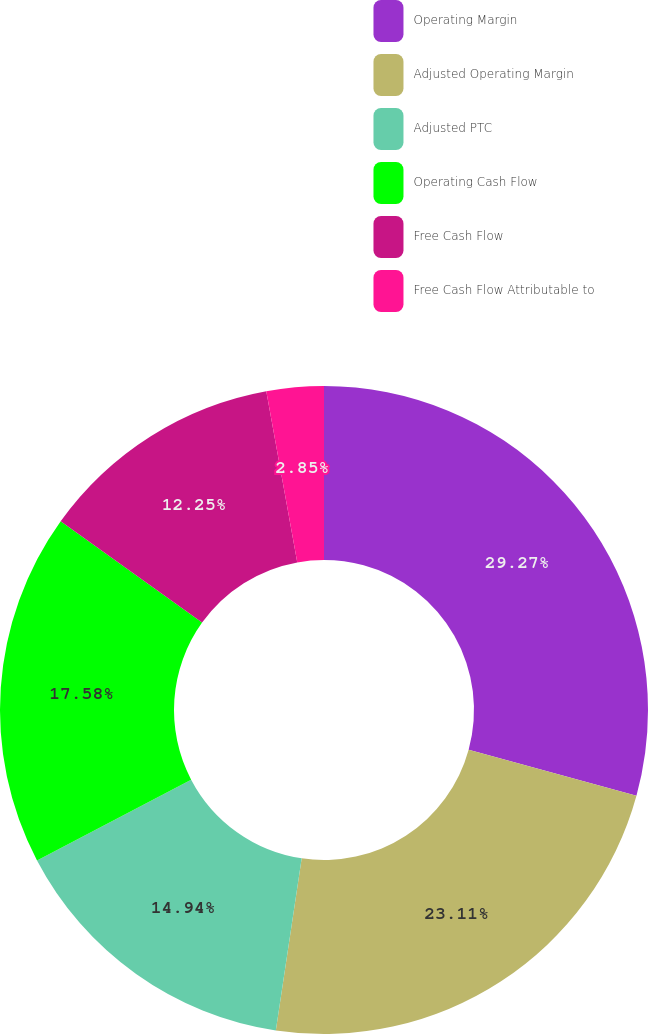Convert chart. <chart><loc_0><loc_0><loc_500><loc_500><pie_chart><fcel>Operating Margin<fcel>Adjusted Operating Margin<fcel>Adjusted PTC<fcel>Operating Cash Flow<fcel>Free Cash Flow<fcel>Free Cash Flow Attributable to<nl><fcel>29.26%<fcel>23.11%<fcel>14.94%<fcel>17.58%<fcel>12.25%<fcel>2.85%<nl></chart> 